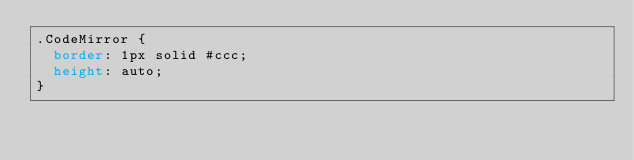Convert code to text. <code><loc_0><loc_0><loc_500><loc_500><_CSS_>.CodeMirror {
  border: 1px solid #ccc;
  height: auto;
}
</code> 